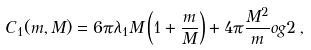Convert formula to latex. <formula><loc_0><loc_0><loc_500><loc_500>C _ { 1 } ( m , M ) = 6 \pi \lambda _ { 1 } M \left ( 1 + \frac { m } { M } \right ) + 4 \pi \frac { M ^ { 2 } } { m } \L o g 2 \, ,</formula> 